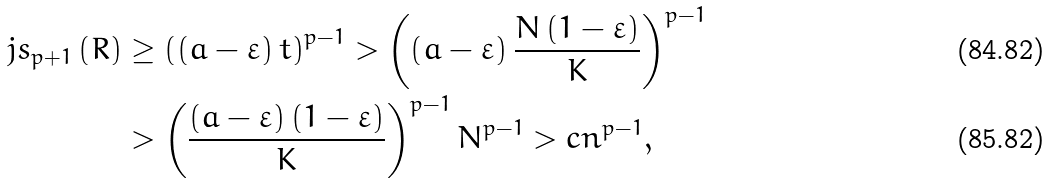<formula> <loc_0><loc_0><loc_500><loc_500>j s _ { p + 1 } \left ( R \right ) & \geq \left ( \left ( a - \varepsilon \right ) t \right ) ^ { p - 1 } > \left ( \left ( a - \varepsilon \right ) \frac { N \left ( 1 - \varepsilon \right ) } { K } \right ) ^ { p - 1 } \\ & > \left ( \frac { \left ( a - \varepsilon \right ) \left ( 1 - \varepsilon \right ) } { K } \right ) ^ { p - 1 } N ^ { p - 1 } > c n ^ { p - 1 } ,</formula> 